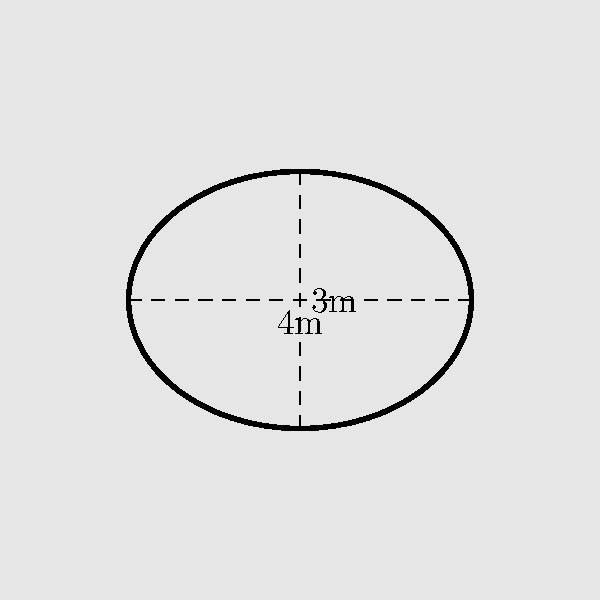During an investigation, you discover a disturbed area of soil that appears to be covering a buried cache of weapons. The surface disturbance forms an elliptical shape with a major axis of 4 meters and a minor axis of 3 meters. Estimate the area of the buried cache, assuming the surface disturbance accurately reflects the cache's dimensions. To estimate the area of the buried cache, we'll use the formula for the area of an ellipse:

1. The formula for the area of an ellipse is:
   $$A = \pi ab$$
   where $a$ is half the length of the major axis and $b$ is half the length of the minor axis.

2. In this case:
   Major axis = 4 meters, so $a = 4/2 = 2$ meters
   Minor axis = 3 meters, so $b = 3/2 = 1.5$ meters

3. Plugging these values into the formula:
   $$A = \pi (2)(1.5)$$

4. Simplify:
   $$A = 3\pi$$

5. Calculate the approximate value:
   $$A \approx 3 \times 3.14159 \approx 9.42477 \text{ m}^2$$

6. Round to two decimal places:
   $$A \approx 9.42 \text{ m}^2$$
Answer: 9.42 m² 